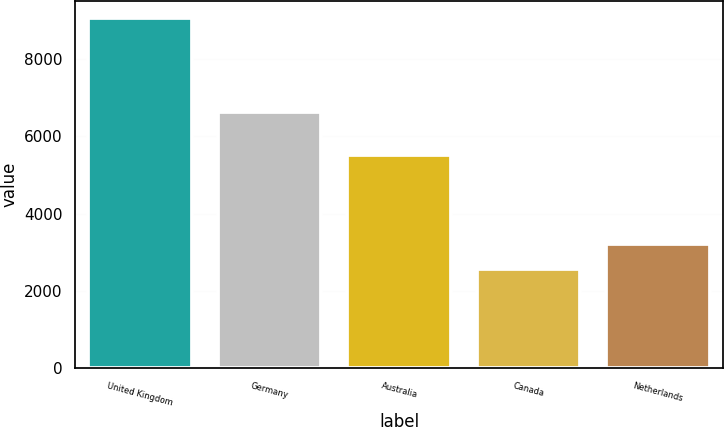Convert chart. <chart><loc_0><loc_0><loc_500><loc_500><bar_chart><fcel>United Kingdom<fcel>Germany<fcel>Australia<fcel>Canada<fcel>Netherlands<nl><fcel>9055<fcel>6626<fcel>5529<fcel>2570<fcel>3218.5<nl></chart> 